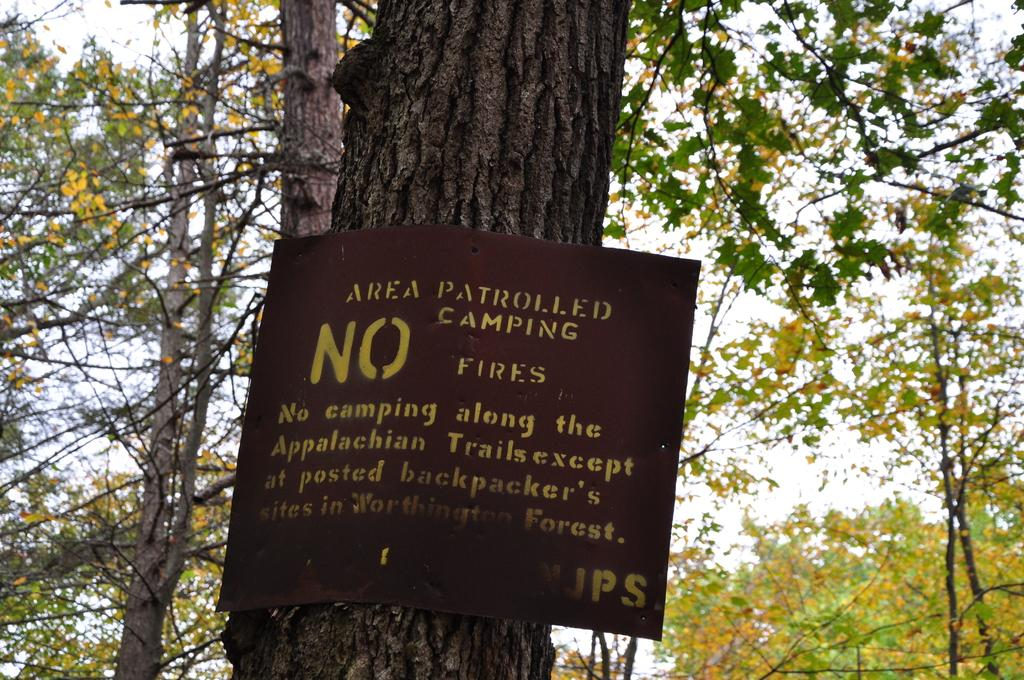What type of natural elements can be seen in the image? There are trees in the image. What man-made object is present in the image? There is a poster with text in the image. How many toys are scattered on the ground in the image? There are no toys present in the image. What time is indicated on the clock in the image? There is no clock present in the image. 